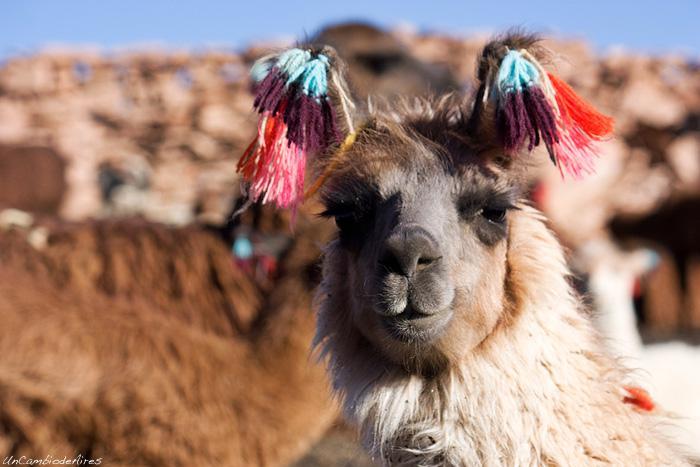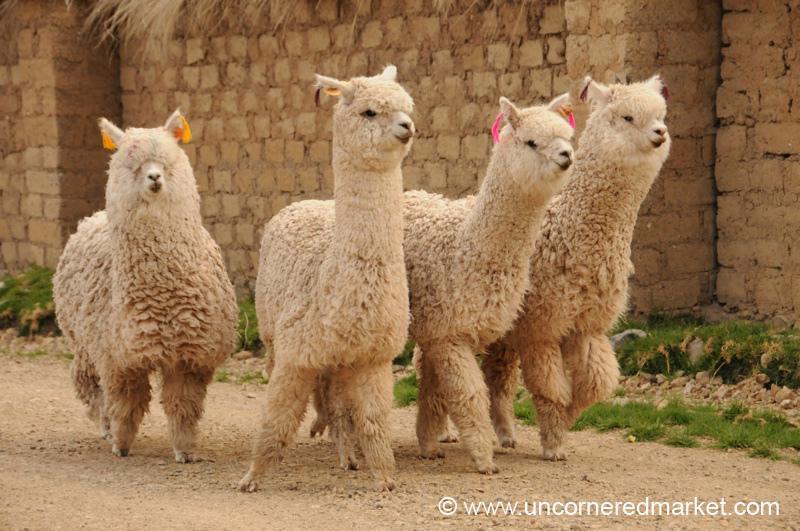The first image is the image on the left, the second image is the image on the right. Evaluate the accuracy of this statement regarding the images: "At least one photo shows an animal with brightly colored tassels near its ears.". Is it true? Answer yes or no. Yes. The first image is the image on the left, the second image is the image on the right. Given the left and right images, does the statement "One of the images shows a llama with multicolored yarn decorations hanging from its ears." hold true? Answer yes or no. Yes. 